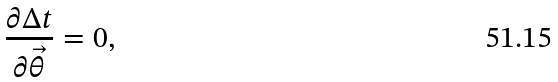Convert formula to latex. <formula><loc_0><loc_0><loc_500><loc_500>\frac { \partial \Delta t } { \partial \vec { \theta } } = 0 ,</formula> 